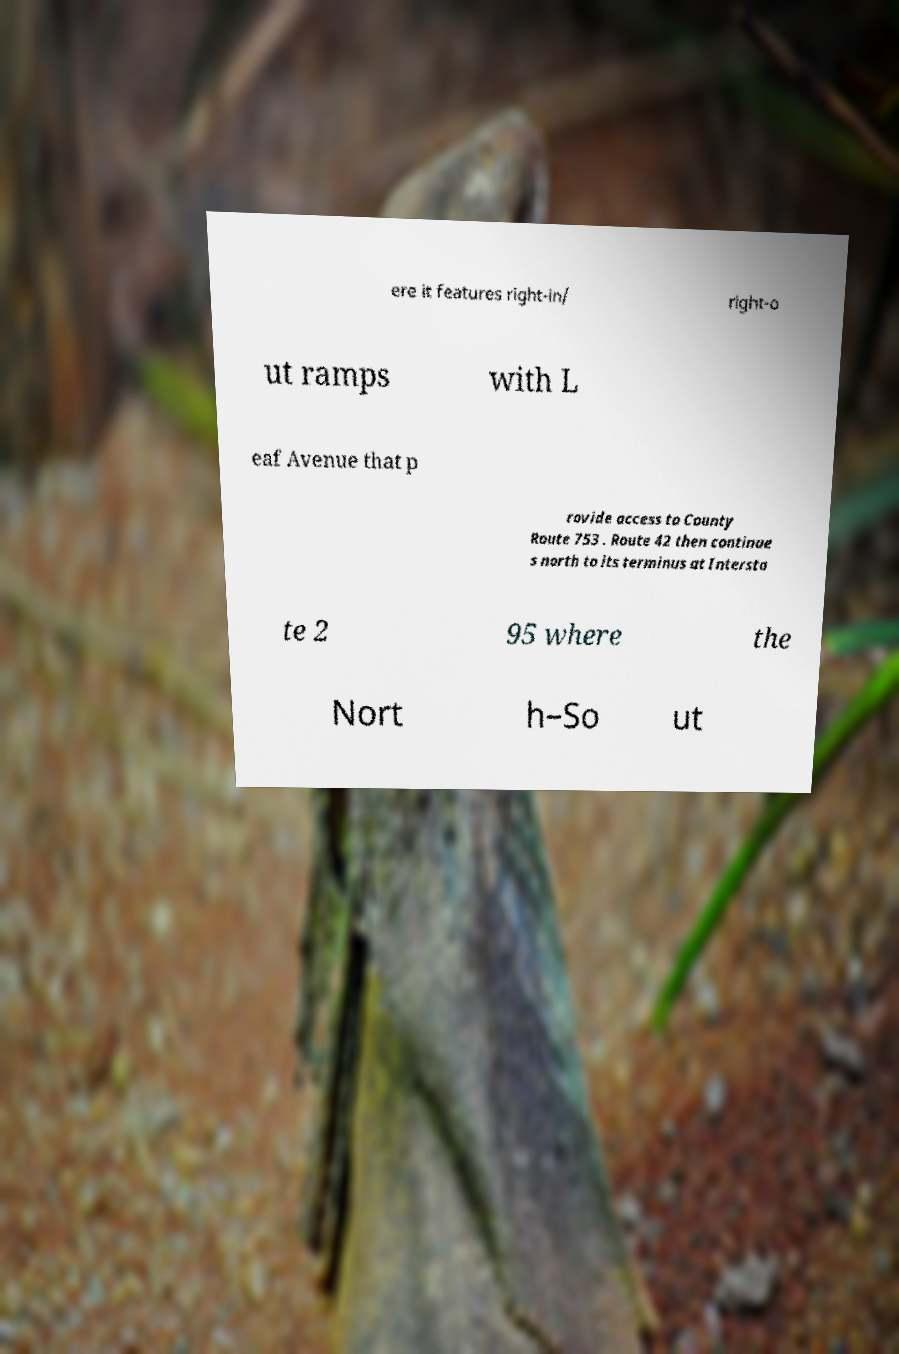Please read and relay the text visible in this image. What does it say? ere it features right-in/ right-o ut ramps with L eaf Avenue that p rovide access to County Route 753 . Route 42 then continue s north to its terminus at Intersta te 2 95 where the Nort h–So ut 